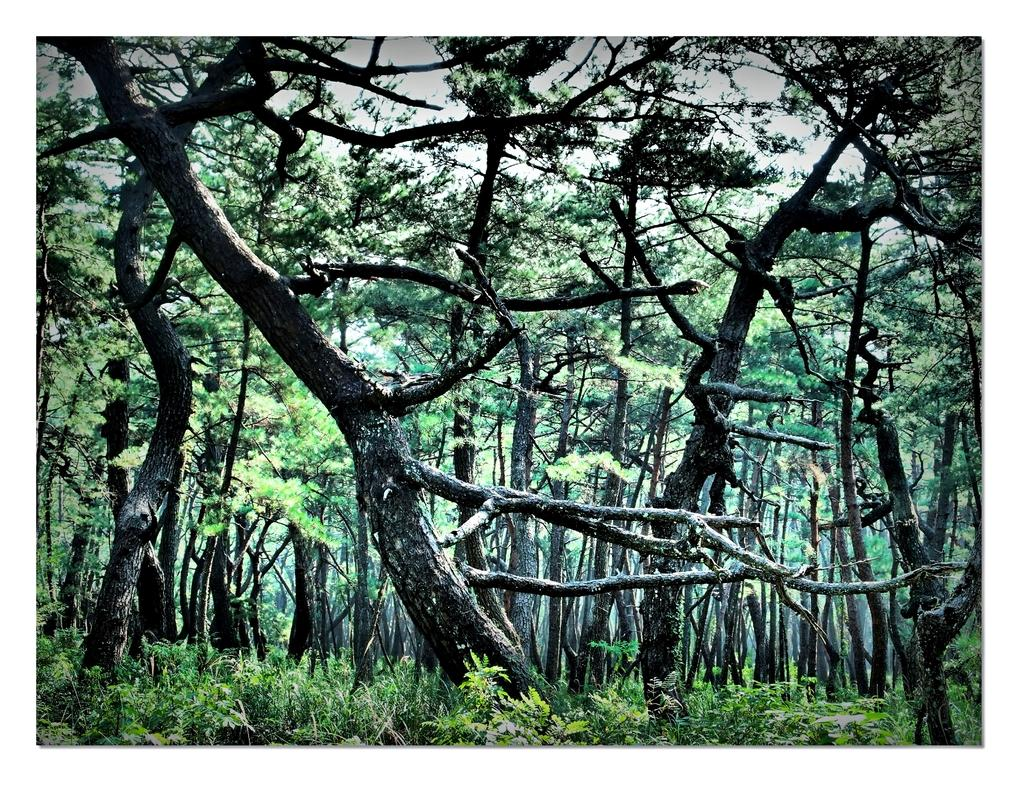What type of vegetation is present in the image? There are dense trees in the image. Can you describe the density of the trees? The trees are dense, indicating that they are closely packed together. What might the presence of dense trees suggest about the location or environment? The presence of dense trees might suggest that the image was taken in a forested area or a location with a high concentration of trees. What type of apparel is being worn by the trees in the image? There are no people or animals present in the image, so there is no apparel to be worn by the trees. 